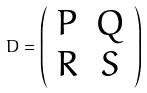<formula> <loc_0><loc_0><loc_500><loc_500>D = \left ( \begin{array} { c c } P & Q \\ R & S \end{array} \right )</formula> 